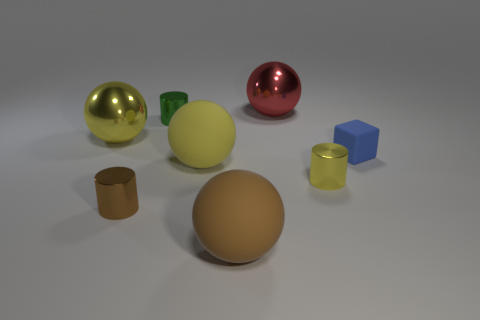Is there a big object made of the same material as the small green cylinder?
Your response must be concise. Yes. What material is the cube that is the same size as the brown metal thing?
Keep it short and to the point. Rubber. What number of large yellow shiny things are the same shape as the yellow matte object?
Provide a short and direct response. 1. There is a red object that is made of the same material as the small yellow thing; what size is it?
Provide a succinct answer. Large. What is the material of the thing that is both to the right of the brown cylinder and in front of the yellow cylinder?
Give a very brief answer. Rubber. How many yellow objects have the same size as the blue rubber cube?
Offer a terse response. 1. There is a large brown thing that is the same shape as the big red metallic thing; what is its material?
Give a very brief answer. Rubber. How many objects are either objects that are behind the brown ball or big things in front of the small green thing?
Make the answer very short. 8. There is a small rubber thing; is its shape the same as the yellow shiny object that is on the right side of the tiny green metal cylinder?
Offer a terse response. No. What is the shape of the large yellow object in front of the large yellow sphere behind the thing on the right side of the small yellow cylinder?
Provide a succinct answer. Sphere. 